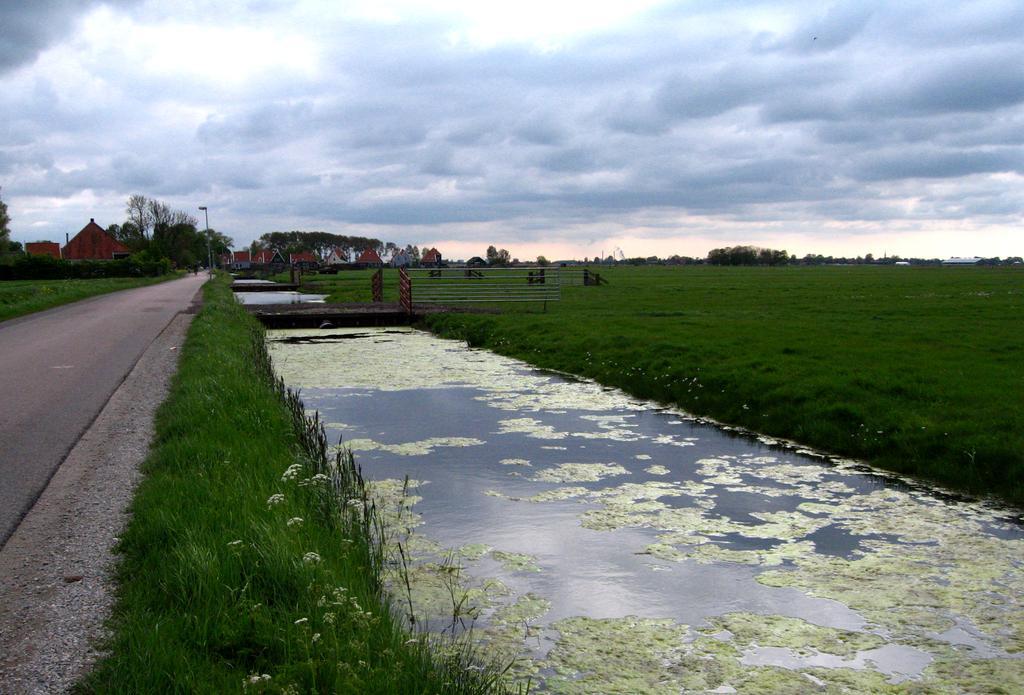In one or two sentences, can you explain what this image depicts? In this image in the center there is water. On the right side there is grass on the ground. In the background there are trees and there are buildings and the sky is cloudy. 